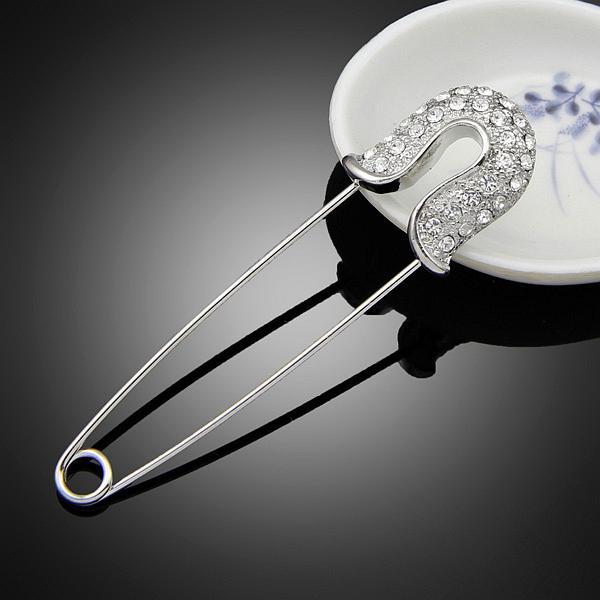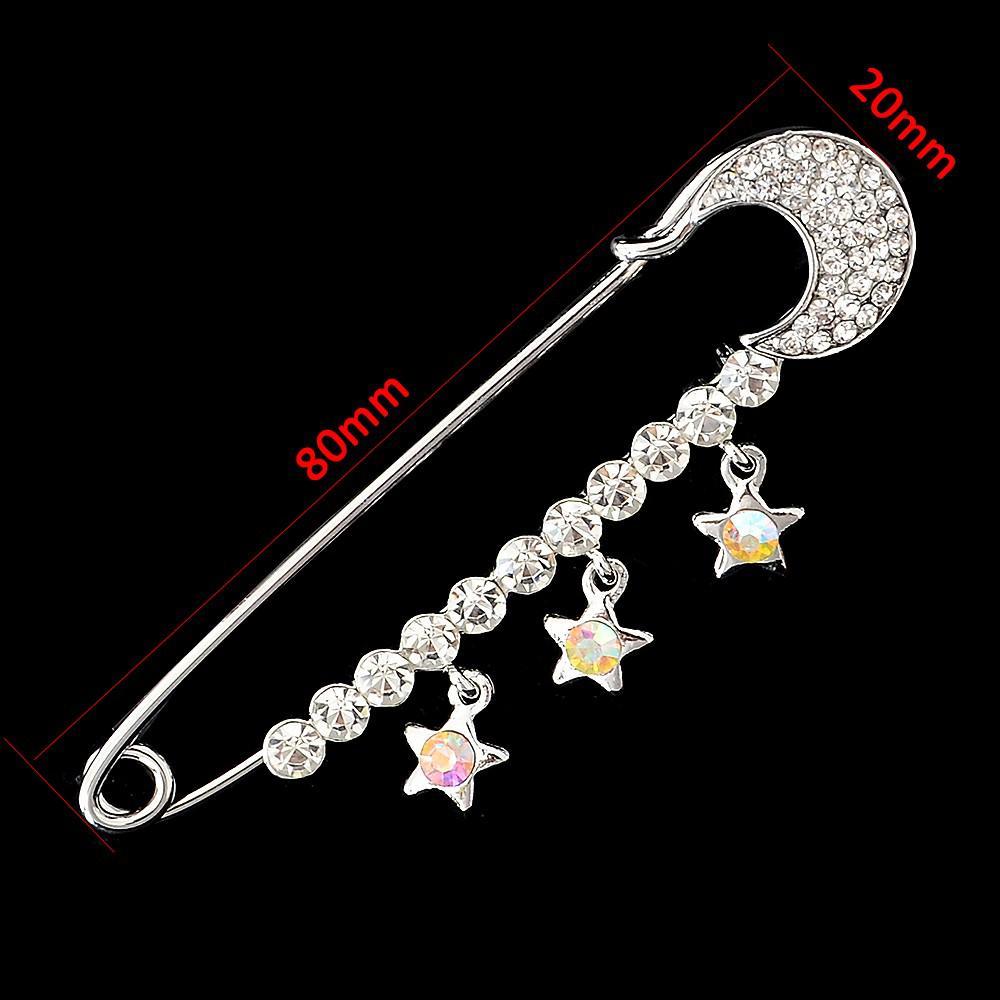The first image is the image on the left, the second image is the image on the right. Examine the images to the left and right. Is the description "1 safety pin is in front of a white dish." accurate? Answer yes or no. Yes. 